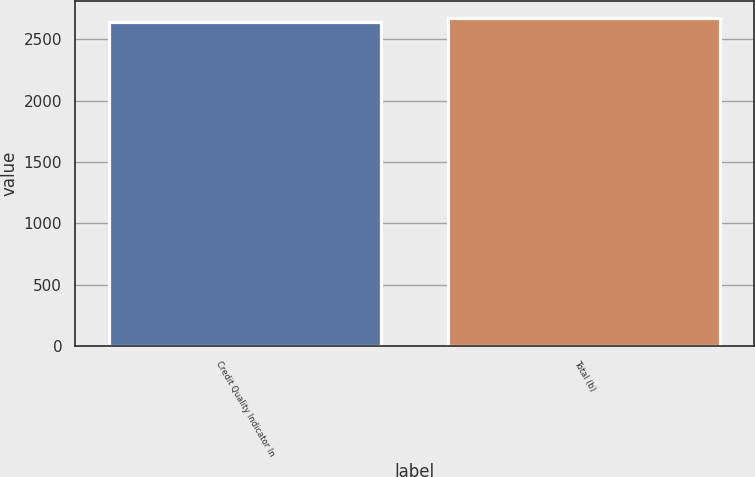<chart> <loc_0><loc_0><loc_500><loc_500><bar_chart><fcel>Credit Quality Indicator In<fcel>Total (b)<nl><fcel>2640<fcel>2673<nl></chart> 